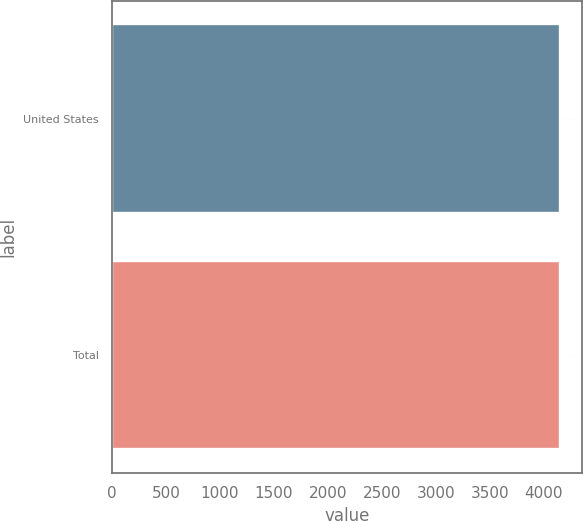Convert chart to OTSL. <chart><loc_0><loc_0><loc_500><loc_500><bar_chart><fcel>United States<fcel>Total<nl><fcel>4144<fcel>4144.1<nl></chart> 